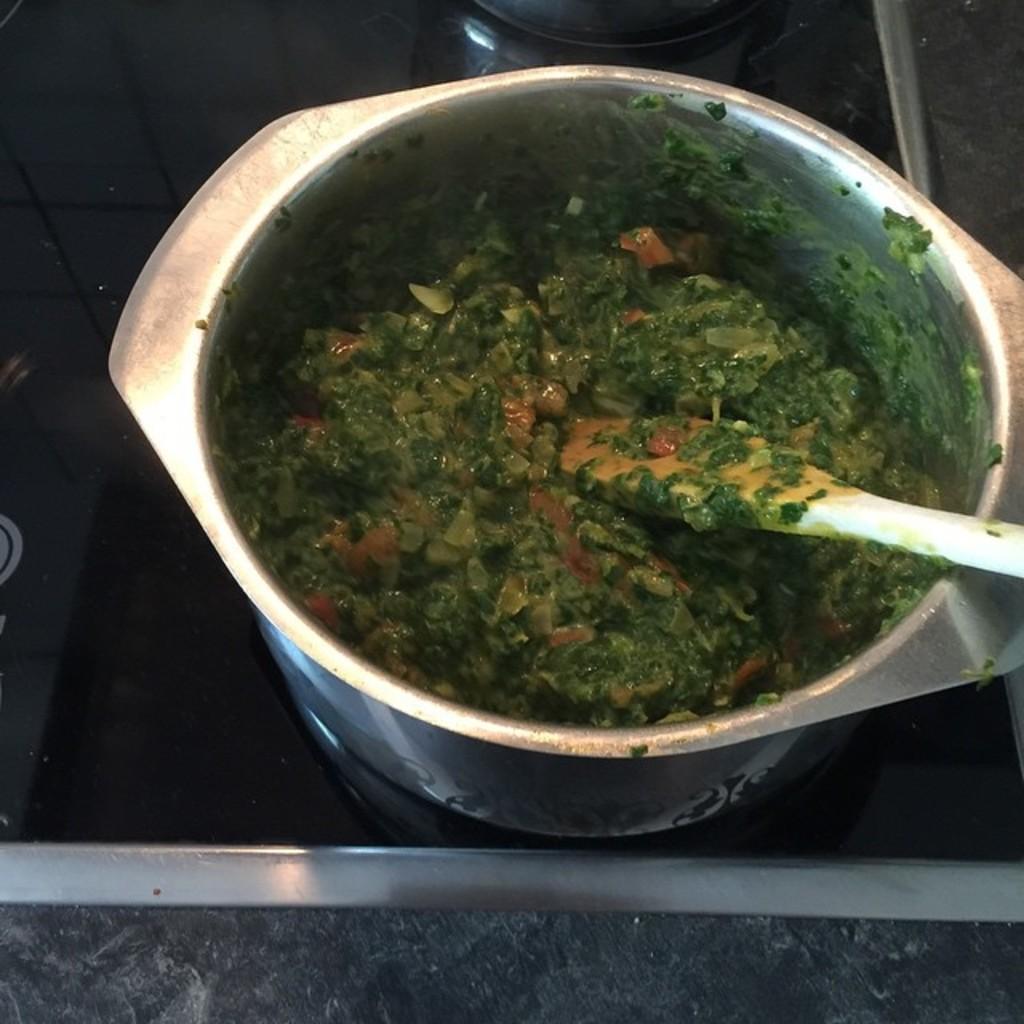In one or two sentences, can you explain what this image depicts? In this food container there is a food and spatula. This food container is on a black surface. 